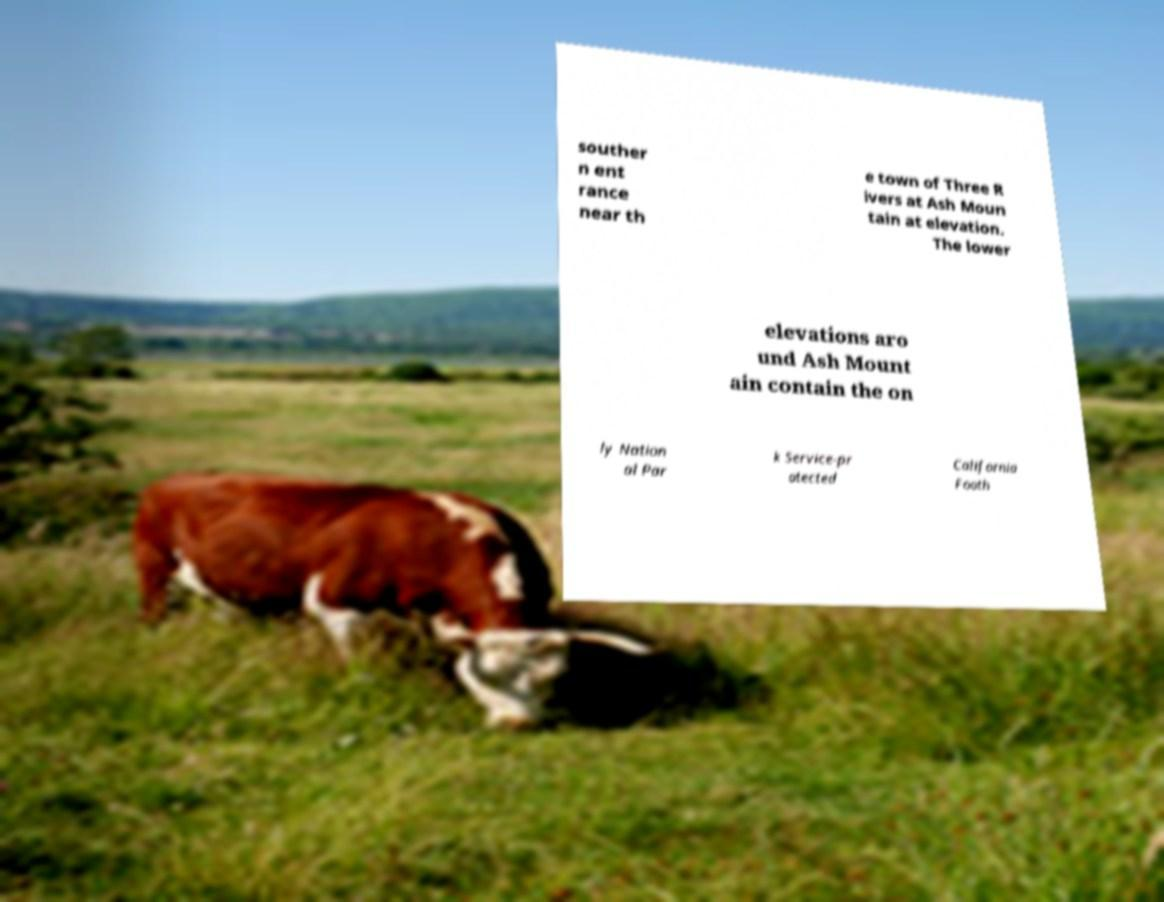For documentation purposes, I need the text within this image transcribed. Could you provide that? souther n ent rance near th e town of Three R ivers at Ash Moun tain at elevation. The lower elevations aro und Ash Mount ain contain the on ly Nation al Par k Service-pr otected California Footh 